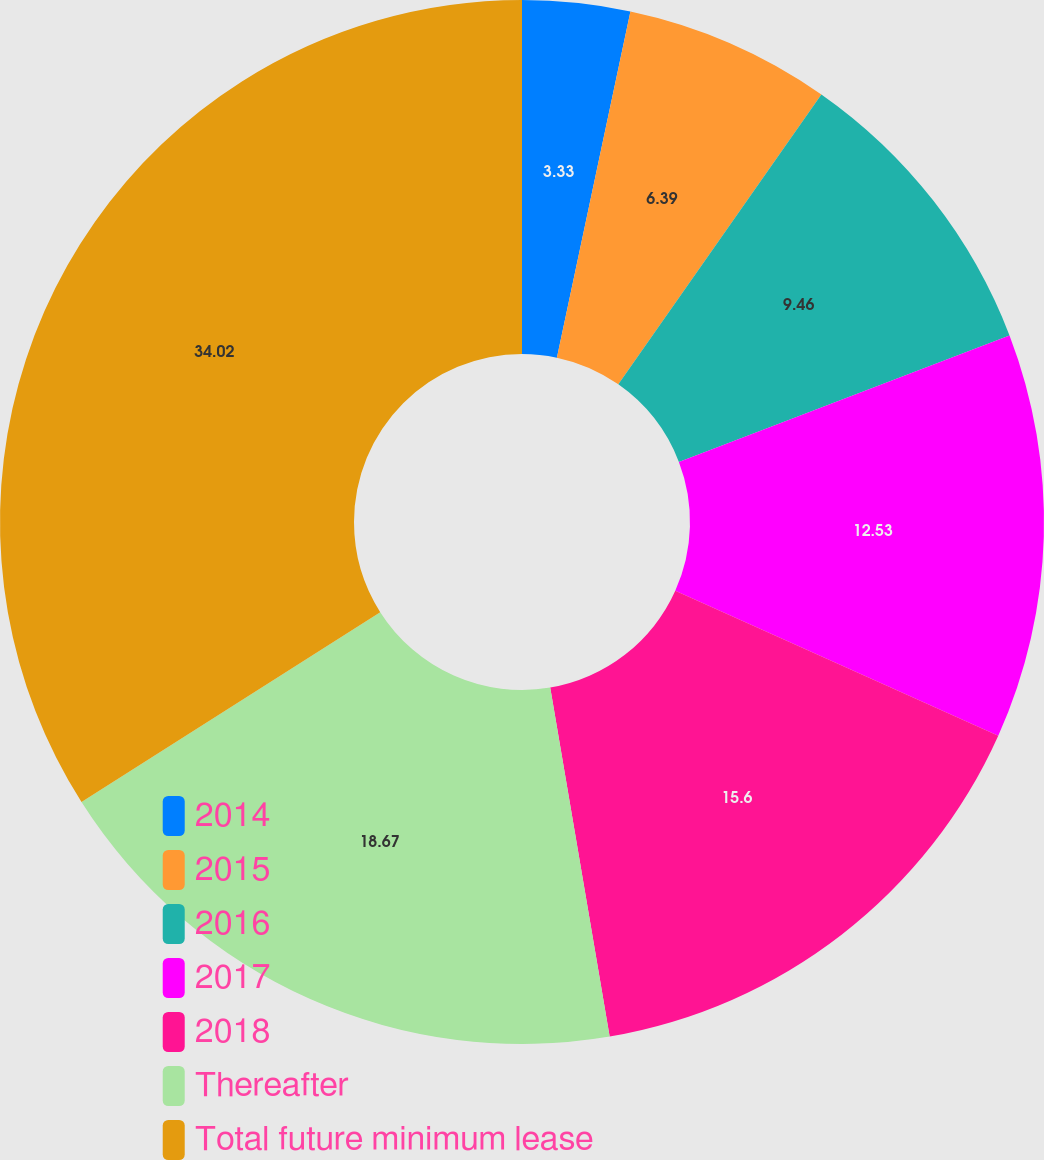<chart> <loc_0><loc_0><loc_500><loc_500><pie_chart><fcel>2014<fcel>2015<fcel>2016<fcel>2017<fcel>2018<fcel>Thereafter<fcel>Total future minimum lease<nl><fcel>3.33%<fcel>6.39%<fcel>9.46%<fcel>12.53%<fcel>15.6%<fcel>18.67%<fcel>34.01%<nl></chart> 